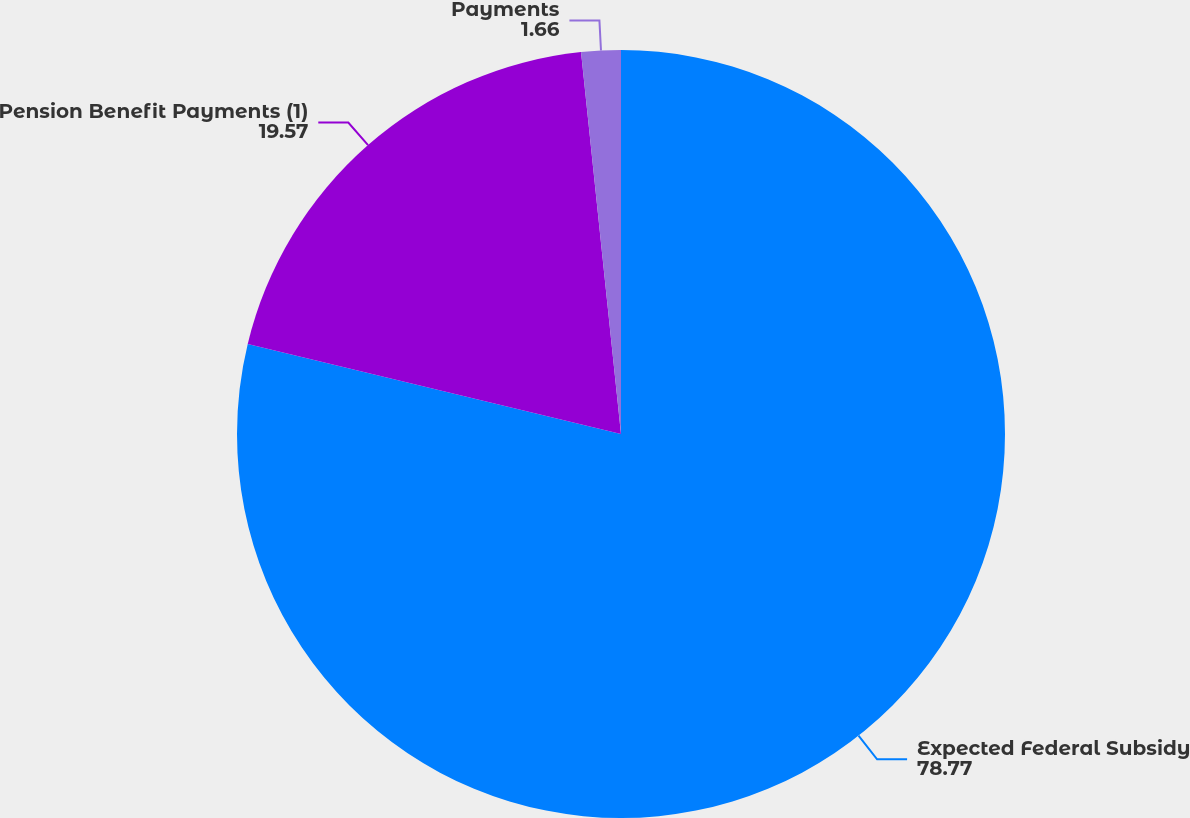Convert chart to OTSL. <chart><loc_0><loc_0><loc_500><loc_500><pie_chart><fcel>Expected Federal Subsidy<fcel>Pension Benefit Payments (1)<fcel>Payments<nl><fcel>78.77%<fcel>19.57%<fcel>1.66%<nl></chart> 